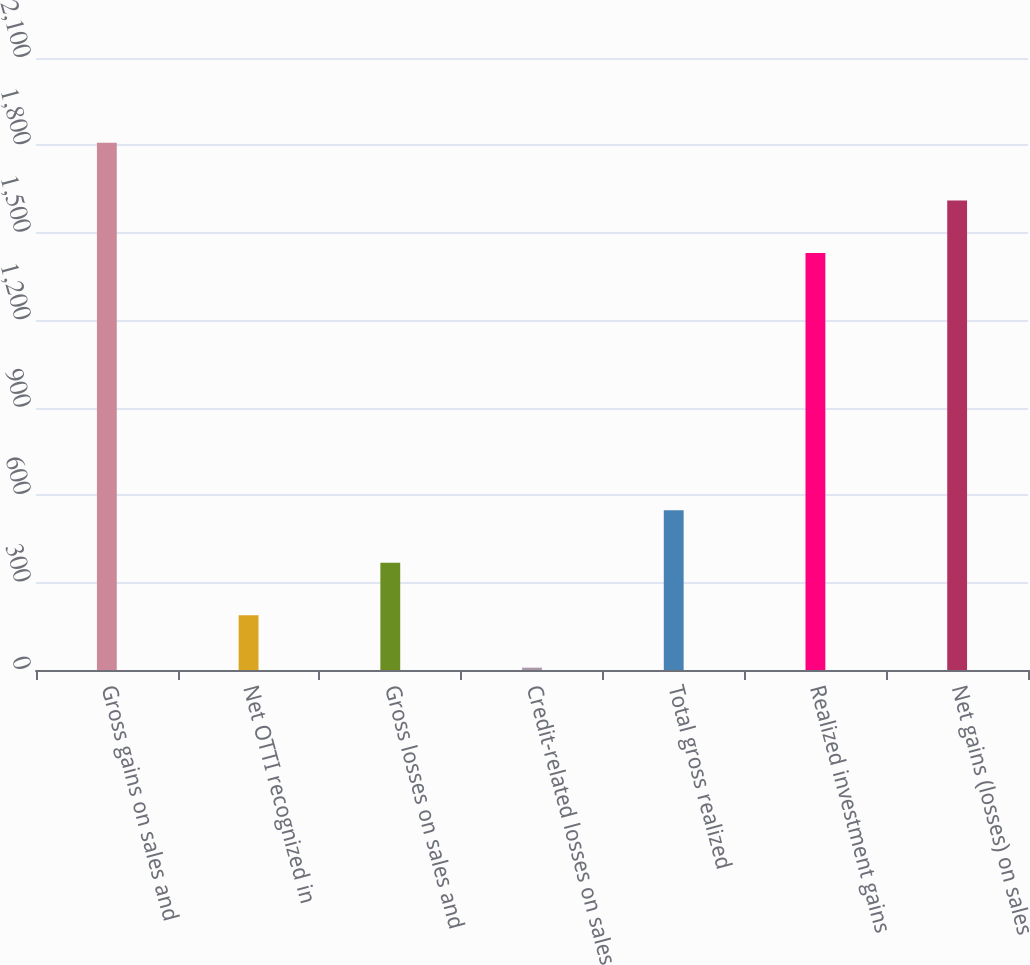Convert chart to OTSL. <chart><loc_0><loc_0><loc_500><loc_500><bar_chart><fcel>Gross gains on sales and<fcel>Net OTTI recognized in<fcel>Gross losses on sales and<fcel>Credit-related losses on sales<fcel>Total gross realized<fcel>Realized investment gains<fcel>Net gains (losses) on sales<nl><fcel>1809<fcel>188.1<fcel>368.2<fcel>8<fcel>548.3<fcel>1431<fcel>1611.1<nl></chart> 